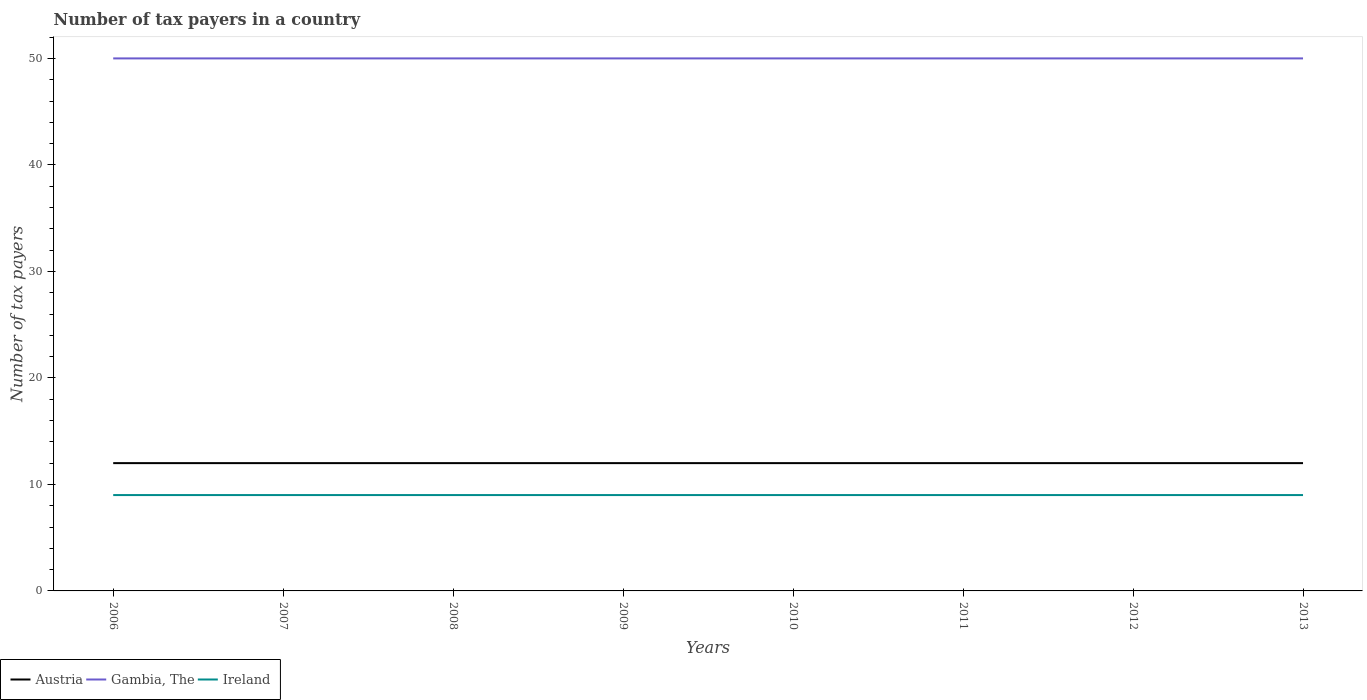How many different coloured lines are there?
Ensure brevity in your answer.  3. Does the line corresponding to Gambia, The intersect with the line corresponding to Ireland?
Offer a terse response. No. Across all years, what is the maximum number of tax payers in in Gambia, The?
Give a very brief answer. 50. In which year was the number of tax payers in in Gambia, The maximum?
Offer a terse response. 2006. What is the difference between the highest and the second highest number of tax payers in in Ireland?
Ensure brevity in your answer.  0. Is the number of tax payers in in Gambia, The strictly greater than the number of tax payers in in Ireland over the years?
Your answer should be very brief. No. Does the graph contain any zero values?
Your response must be concise. No. Does the graph contain grids?
Your answer should be very brief. No. How many legend labels are there?
Keep it short and to the point. 3. How are the legend labels stacked?
Provide a succinct answer. Horizontal. What is the title of the graph?
Give a very brief answer. Number of tax payers in a country. What is the label or title of the X-axis?
Make the answer very short. Years. What is the label or title of the Y-axis?
Offer a terse response. Number of tax payers. What is the Number of tax payers of Austria in 2006?
Your answer should be very brief. 12. What is the Number of tax payers of Gambia, The in 2006?
Offer a terse response. 50. What is the Number of tax payers of Austria in 2007?
Provide a succinct answer. 12. What is the Number of tax payers in Gambia, The in 2007?
Your answer should be compact. 50. What is the Number of tax payers of Ireland in 2007?
Your answer should be compact. 9. What is the Number of tax payers of Austria in 2008?
Make the answer very short. 12. What is the Number of tax payers of Gambia, The in 2008?
Keep it short and to the point. 50. What is the Number of tax payers of Austria in 2009?
Provide a short and direct response. 12. What is the Number of tax payers of Ireland in 2010?
Your answer should be very brief. 9. What is the Number of tax payers in Austria in 2011?
Ensure brevity in your answer.  12. What is the Number of tax payers of Ireland in 2012?
Offer a terse response. 9. What is the Number of tax payers in Austria in 2013?
Your answer should be very brief. 12. What is the Number of tax payers in Gambia, The in 2013?
Your answer should be compact. 50. What is the Number of tax payers of Ireland in 2013?
Your response must be concise. 9. Across all years, what is the maximum Number of tax payers of Austria?
Offer a very short reply. 12. Across all years, what is the maximum Number of tax payers of Gambia, The?
Give a very brief answer. 50. Across all years, what is the maximum Number of tax payers of Ireland?
Your answer should be very brief. 9. Across all years, what is the minimum Number of tax payers in Gambia, The?
Offer a terse response. 50. Across all years, what is the minimum Number of tax payers of Ireland?
Offer a very short reply. 9. What is the total Number of tax payers in Austria in the graph?
Give a very brief answer. 96. What is the total Number of tax payers of Gambia, The in the graph?
Ensure brevity in your answer.  400. What is the difference between the Number of tax payers in Gambia, The in 2006 and that in 2007?
Your response must be concise. 0. What is the difference between the Number of tax payers of Ireland in 2006 and that in 2007?
Offer a very short reply. 0. What is the difference between the Number of tax payers of Ireland in 2006 and that in 2009?
Keep it short and to the point. 0. What is the difference between the Number of tax payers of Gambia, The in 2006 and that in 2010?
Provide a succinct answer. 0. What is the difference between the Number of tax payers in Ireland in 2006 and that in 2010?
Provide a short and direct response. 0. What is the difference between the Number of tax payers in Austria in 2006 and that in 2011?
Ensure brevity in your answer.  0. What is the difference between the Number of tax payers in Gambia, The in 2006 and that in 2012?
Offer a very short reply. 0. What is the difference between the Number of tax payers in Ireland in 2006 and that in 2012?
Give a very brief answer. 0. What is the difference between the Number of tax payers in Austria in 2006 and that in 2013?
Your answer should be compact. 0. What is the difference between the Number of tax payers in Gambia, The in 2007 and that in 2008?
Ensure brevity in your answer.  0. What is the difference between the Number of tax payers of Ireland in 2007 and that in 2008?
Give a very brief answer. 0. What is the difference between the Number of tax payers in Austria in 2007 and that in 2009?
Provide a short and direct response. 0. What is the difference between the Number of tax payers in Gambia, The in 2007 and that in 2009?
Provide a short and direct response. 0. What is the difference between the Number of tax payers of Austria in 2007 and that in 2010?
Your answer should be compact. 0. What is the difference between the Number of tax payers in Gambia, The in 2007 and that in 2010?
Provide a succinct answer. 0. What is the difference between the Number of tax payers in Ireland in 2007 and that in 2010?
Your answer should be very brief. 0. What is the difference between the Number of tax payers in Austria in 2007 and that in 2011?
Keep it short and to the point. 0. What is the difference between the Number of tax payers of Gambia, The in 2007 and that in 2012?
Keep it short and to the point. 0. What is the difference between the Number of tax payers of Ireland in 2007 and that in 2012?
Provide a succinct answer. 0. What is the difference between the Number of tax payers in Gambia, The in 2007 and that in 2013?
Your answer should be compact. 0. What is the difference between the Number of tax payers in Ireland in 2007 and that in 2013?
Keep it short and to the point. 0. What is the difference between the Number of tax payers of Austria in 2008 and that in 2010?
Your answer should be compact. 0. What is the difference between the Number of tax payers of Gambia, The in 2008 and that in 2010?
Provide a succinct answer. 0. What is the difference between the Number of tax payers in Ireland in 2008 and that in 2010?
Offer a very short reply. 0. What is the difference between the Number of tax payers in Ireland in 2008 and that in 2011?
Your response must be concise. 0. What is the difference between the Number of tax payers in Austria in 2009 and that in 2010?
Ensure brevity in your answer.  0. What is the difference between the Number of tax payers in Austria in 2009 and that in 2011?
Make the answer very short. 0. What is the difference between the Number of tax payers of Ireland in 2009 and that in 2011?
Your answer should be very brief. 0. What is the difference between the Number of tax payers of Gambia, The in 2009 and that in 2012?
Your answer should be very brief. 0. What is the difference between the Number of tax payers of Austria in 2009 and that in 2013?
Make the answer very short. 0. What is the difference between the Number of tax payers of Gambia, The in 2009 and that in 2013?
Provide a short and direct response. 0. What is the difference between the Number of tax payers of Austria in 2010 and that in 2012?
Ensure brevity in your answer.  0. What is the difference between the Number of tax payers in Gambia, The in 2010 and that in 2012?
Keep it short and to the point. 0. What is the difference between the Number of tax payers of Ireland in 2010 and that in 2012?
Keep it short and to the point. 0. What is the difference between the Number of tax payers of Ireland in 2010 and that in 2013?
Give a very brief answer. 0. What is the difference between the Number of tax payers of Austria in 2011 and that in 2012?
Give a very brief answer. 0. What is the difference between the Number of tax payers in Gambia, The in 2011 and that in 2012?
Give a very brief answer. 0. What is the difference between the Number of tax payers in Austria in 2011 and that in 2013?
Provide a succinct answer. 0. What is the difference between the Number of tax payers in Gambia, The in 2011 and that in 2013?
Make the answer very short. 0. What is the difference between the Number of tax payers in Ireland in 2011 and that in 2013?
Your response must be concise. 0. What is the difference between the Number of tax payers of Austria in 2012 and that in 2013?
Ensure brevity in your answer.  0. What is the difference between the Number of tax payers in Gambia, The in 2012 and that in 2013?
Give a very brief answer. 0. What is the difference between the Number of tax payers of Ireland in 2012 and that in 2013?
Provide a succinct answer. 0. What is the difference between the Number of tax payers of Austria in 2006 and the Number of tax payers of Gambia, The in 2007?
Give a very brief answer. -38. What is the difference between the Number of tax payers in Austria in 2006 and the Number of tax payers in Ireland in 2007?
Give a very brief answer. 3. What is the difference between the Number of tax payers in Gambia, The in 2006 and the Number of tax payers in Ireland in 2007?
Offer a very short reply. 41. What is the difference between the Number of tax payers in Austria in 2006 and the Number of tax payers in Gambia, The in 2008?
Your answer should be very brief. -38. What is the difference between the Number of tax payers of Austria in 2006 and the Number of tax payers of Ireland in 2008?
Make the answer very short. 3. What is the difference between the Number of tax payers in Gambia, The in 2006 and the Number of tax payers in Ireland in 2008?
Your answer should be compact. 41. What is the difference between the Number of tax payers of Austria in 2006 and the Number of tax payers of Gambia, The in 2009?
Your answer should be compact. -38. What is the difference between the Number of tax payers of Austria in 2006 and the Number of tax payers of Ireland in 2009?
Offer a very short reply. 3. What is the difference between the Number of tax payers of Austria in 2006 and the Number of tax payers of Gambia, The in 2010?
Make the answer very short. -38. What is the difference between the Number of tax payers of Austria in 2006 and the Number of tax payers of Ireland in 2010?
Your answer should be very brief. 3. What is the difference between the Number of tax payers in Austria in 2006 and the Number of tax payers in Gambia, The in 2011?
Offer a very short reply. -38. What is the difference between the Number of tax payers of Austria in 2006 and the Number of tax payers of Ireland in 2011?
Give a very brief answer. 3. What is the difference between the Number of tax payers in Gambia, The in 2006 and the Number of tax payers in Ireland in 2011?
Your answer should be compact. 41. What is the difference between the Number of tax payers in Austria in 2006 and the Number of tax payers in Gambia, The in 2012?
Offer a terse response. -38. What is the difference between the Number of tax payers in Austria in 2006 and the Number of tax payers in Ireland in 2012?
Your answer should be very brief. 3. What is the difference between the Number of tax payers of Austria in 2006 and the Number of tax payers of Gambia, The in 2013?
Offer a terse response. -38. What is the difference between the Number of tax payers of Gambia, The in 2006 and the Number of tax payers of Ireland in 2013?
Offer a very short reply. 41. What is the difference between the Number of tax payers of Austria in 2007 and the Number of tax payers of Gambia, The in 2008?
Give a very brief answer. -38. What is the difference between the Number of tax payers of Gambia, The in 2007 and the Number of tax payers of Ireland in 2008?
Provide a succinct answer. 41. What is the difference between the Number of tax payers in Austria in 2007 and the Number of tax payers in Gambia, The in 2009?
Provide a succinct answer. -38. What is the difference between the Number of tax payers of Austria in 2007 and the Number of tax payers of Gambia, The in 2010?
Your response must be concise. -38. What is the difference between the Number of tax payers in Austria in 2007 and the Number of tax payers in Gambia, The in 2011?
Offer a very short reply. -38. What is the difference between the Number of tax payers of Gambia, The in 2007 and the Number of tax payers of Ireland in 2011?
Offer a very short reply. 41. What is the difference between the Number of tax payers in Austria in 2007 and the Number of tax payers in Gambia, The in 2012?
Make the answer very short. -38. What is the difference between the Number of tax payers of Austria in 2007 and the Number of tax payers of Gambia, The in 2013?
Provide a succinct answer. -38. What is the difference between the Number of tax payers of Austria in 2007 and the Number of tax payers of Ireland in 2013?
Give a very brief answer. 3. What is the difference between the Number of tax payers in Gambia, The in 2007 and the Number of tax payers in Ireland in 2013?
Your answer should be very brief. 41. What is the difference between the Number of tax payers in Austria in 2008 and the Number of tax payers in Gambia, The in 2009?
Offer a terse response. -38. What is the difference between the Number of tax payers of Austria in 2008 and the Number of tax payers of Ireland in 2009?
Your response must be concise. 3. What is the difference between the Number of tax payers of Austria in 2008 and the Number of tax payers of Gambia, The in 2010?
Provide a short and direct response. -38. What is the difference between the Number of tax payers in Austria in 2008 and the Number of tax payers in Gambia, The in 2011?
Offer a very short reply. -38. What is the difference between the Number of tax payers in Austria in 2008 and the Number of tax payers in Ireland in 2011?
Make the answer very short. 3. What is the difference between the Number of tax payers of Gambia, The in 2008 and the Number of tax payers of Ireland in 2011?
Your answer should be very brief. 41. What is the difference between the Number of tax payers of Austria in 2008 and the Number of tax payers of Gambia, The in 2012?
Give a very brief answer. -38. What is the difference between the Number of tax payers of Gambia, The in 2008 and the Number of tax payers of Ireland in 2012?
Your answer should be very brief. 41. What is the difference between the Number of tax payers in Austria in 2008 and the Number of tax payers in Gambia, The in 2013?
Offer a very short reply. -38. What is the difference between the Number of tax payers of Austria in 2008 and the Number of tax payers of Ireland in 2013?
Give a very brief answer. 3. What is the difference between the Number of tax payers of Austria in 2009 and the Number of tax payers of Gambia, The in 2010?
Make the answer very short. -38. What is the difference between the Number of tax payers in Austria in 2009 and the Number of tax payers in Ireland in 2010?
Ensure brevity in your answer.  3. What is the difference between the Number of tax payers in Austria in 2009 and the Number of tax payers in Gambia, The in 2011?
Make the answer very short. -38. What is the difference between the Number of tax payers of Gambia, The in 2009 and the Number of tax payers of Ireland in 2011?
Your response must be concise. 41. What is the difference between the Number of tax payers in Austria in 2009 and the Number of tax payers in Gambia, The in 2012?
Ensure brevity in your answer.  -38. What is the difference between the Number of tax payers of Austria in 2009 and the Number of tax payers of Gambia, The in 2013?
Your answer should be compact. -38. What is the difference between the Number of tax payers of Austria in 2010 and the Number of tax payers of Gambia, The in 2011?
Offer a very short reply. -38. What is the difference between the Number of tax payers in Austria in 2010 and the Number of tax payers in Ireland in 2011?
Keep it short and to the point. 3. What is the difference between the Number of tax payers in Gambia, The in 2010 and the Number of tax payers in Ireland in 2011?
Give a very brief answer. 41. What is the difference between the Number of tax payers in Austria in 2010 and the Number of tax payers in Gambia, The in 2012?
Offer a terse response. -38. What is the difference between the Number of tax payers of Austria in 2010 and the Number of tax payers of Ireland in 2012?
Provide a succinct answer. 3. What is the difference between the Number of tax payers of Austria in 2010 and the Number of tax payers of Gambia, The in 2013?
Keep it short and to the point. -38. What is the difference between the Number of tax payers in Austria in 2011 and the Number of tax payers in Gambia, The in 2012?
Give a very brief answer. -38. What is the difference between the Number of tax payers of Austria in 2011 and the Number of tax payers of Ireland in 2012?
Provide a short and direct response. 3. What is the difference between the Number of tax payers in Gambia, The in 2011 and the Number of tax payers in Ireland in 2012?
Provide a short and direct response. 41. What is the difference between the Number of tax payers in Austria in 2011 and the Number of tax payers in Gambia, The in 2013?
Give a very brief answer. -38. What is the difference between the Number of tax payers in Austria in 2012 and the Number of tax payers in Gambia, The in 2013?
Offer a terse response. -38. What is the difference between the Number of tax payers in Gambia, The in 2012 and the Number of tax payers in Ireland in 2013?
Provide a succinct answer. 41. What is the average Number of tax payers of Gambia, The per year?
Your answer should be compact. 50. What is the average Number of tax payers in Ireland per year?
Provide a succinct answer. 9. In the year 2006, what is the difference between the Number of tax payers in Austria and Number of tax payers in Gambia, The?
Ensure brevity in your answer.  -38. In the year 2006, what is the difference between the Number of tax payers in Gambia, The and Number of tax payers in Ireland?
Provide a succinct answer. 41. In the year 2007, what is the difference between the Number of tax payers in Austria and Number of tax payers in Gambia, The?
Offer a terse response. -38. In the year 2007, what is the difference between the Number of tax payers of Austria and Number of tax payers of Ireland?
Ensure brevity in your answer.  3. In the year 2007, what is the difference between the Number of tax payers of Gambia, The and Number of tax payers of Ireland?
Offer a terse response. 41. In the year 2008, what is the difference between the Number of tax payers of Austria and Number of tax payers of Gambia, The?
Ensure brevity in your answer.  -38. In the year 2008, what is the difference between the Number of tax payers in Austria and Number of tax payers in Ireland?
Keep it short and to the point. 3. In the year 2009, what is the difference between the Number of tax payers of Austria and Number of tax payers of Gambia, The?
Provide a succinct answer. -38. In the year 2010, what is the difference between the Number of tax payers of Austria and Number of tax payers of Gambia, The?
Keep it short and to the point. -38. In the year 2011, what is the difference between the Number of tax payers of Austria and Number of tax payers of Gambia, The?
Offer a terse response. -38. In the year 2012, what is the difference between the Number of tax payers in Austria and Number of tax payers in Gambia, The?
Your response must be concise. -38. In the year 2012, what is the difference between the Number of tax payers of Austria and Number of tax payers of Ireland?
Give a very brief answer. 3. In the year 2012, what is the difference between the Number of tax payers of Gambia, The and Number of tax payers of Ireland?
Ensure brevity in your answer.  41. In the year 2013, what is the difference between the Number of tax payers in Austria and Number of tax payers in Gambia, The?
Your answer should be compact. -38. In the year 2013, what is the difference between the Number of tax payers of Austria and Number of tax payers of Ireland?
Your response must be concise. 3. In the year 2013, what is the difference between the Number of tax payers in Gambia, The and Number of tax payers in Ireland?
Your answer should be compact. 41. What is the ratio of the Number of tax payers of Austria in 2006 to that in 2007?
Give a very brief answer. 1. What is the ratio of the Number of tax payers in Gambia, The in 2006 to that in 2007?
Offer a very short reply. 1. What is the ratio of the Number of tax payers of Ireland in 2006 to that in 2007?
Your answer should be very brief. 1. What is the ratio of the Number of tax payers in Austria in 2006 to that in 2008?
Provide a short and direct response. 1. What is the ratio of the Number of tax payers of Ireland in 2006 to that in 2009?
Your response must be concise. 1. What is the ratio of the Number of tax payers of Austria in 2006 to that in 2011?
Give a very brief answer. 1. What is the ratio of the Number of tax payers in Ireland in 2006 to that in 2011?
Make the answer very short. 1. What is the ratio of the Number of tax payers of Austria in 2006 to that in 2012?
Offer a terse response. 1. What is the ratio of the Number of tax payers in Gambia, The in 2006 to that in 2012?
Keep it short and to the point. 1. What is the ratio of the Number of tax payers in Gambia, The in 2006 to that in 2013?
Offer a terse response. 1. What is the ratio of the Number of tax payers of Ireland in 2007 to that in 2008?
Offer a very short reply. 1. What is the ratio of the Number of tax payers of Austria in 2007 to that in 2009?
Your response must be concise. 1. What is the ratio of the Number of tax payers in Ireland in 2007 to that in 2009?
Offer a very short reply. 1. What is the ratio of the Number of tax payers in Austria in 2007 to that in 2010?
Your answer should be very brief. 1. What is the ratio of the Number of tax payers of Ireland in 2007 to that in 2010?
Give a very brief answer. 1. What is the ratio of the Number of tax payers in Austria in 2007 to that in 2011?
Your response must be concise. 1. What is the ratio of the Number of tax payers in Gambia, The in 2007 to that in 2011?
Make the answer very short. 1. What is the ratio of the Number of tax payers of Austria in 2007 to that in 2012?
Your answer should be very brief. 1. What is the ratio of the Number of tax payers in Ireland in 2007 to that in 2012?
Your answer should be compact. 1. What is the ratio of the Number of tax payers of Gambia, The in 2007 to that in 2013?
Give a very brief answer. 1. What is the ratio of the Number of tax payers in Ireland in 2007 to that in 2013?
Keep it short and to the point. 1. What is the ratio of the Number of tax payers of Gambia, The in 2008 to that in 2009?
Keep it short and to the point. 1. What is the ratio of the Number of tax payers of Austria in 2008 to that in 2010?
Ensure brevity in your answer.  1. What is the ratio of the Number of tax payers in Gambia, The in 2008 to that in 2010?
Your answer should be very brief. 1. What is the ratio of the Number of tax payers of Ireland in 2008 to that in 2011?
Provide a succinct answer. 1. What is the ratio of the Number of tax payers in Austria in 2008 to that in 2012?
Your response must be concise. 1. What is the ratio of the Number of tax payers of Austria in 2008 to that in 2013?
Your response must be concise. 1. What is the ratio of the Number of tax payers of Gambia, The in 2009 to that in 2010?
Keep it short and to the point. 1. What is the ratio of the Number of tax payers of Ireland in 2009 to that in 2010?
Provide a succinct answer. 1. What is the ratio of the Number of tax payers in Austria in 2009 to that in 2011?
Your response must be concise. 1. What is the ratio of the Number of tax payers in Ireland in 2009 to that in 2011?
Your answer should be very brief. 1. What is the ratio of the Number of tax payers in Austria in 2009 to that in 2012?
Ensure brevity in your answer.  1. What is the ratio of the Number of tax payers of Gambia, The in 2009 to that in 2012?
Ensure brevity in your answer.  1. What is the ratio of the Number of tax payers of Ireland in 2009 to that in 2012?
Your response must be concise. 1. What is the ratio of the Number of tax payers in Austria in 2010 to that in 2011?
Offer a terse response. 1. What is the ratio of the Number of tax payers of Ireland in 2010 to that in 2013?
Ensure brevity in your answer.  1. What is the ratio of the Number of tax payers in Austria in 2011 to that in 2012?
Ensure brevity in your answer.  1. What is the ratio of the Number of tax payers in Gambia, The in 2011 to that in 2012?
Offer a very short reply. 1. What is the ratio of the Number of tax payers in Austria in 2011 to that in 2013?
Provide a short and direct response. 1. What is the ratio of the Number of tax payers in Gambia, The in 2011 to that in 2013?
Ensure brevity in your answer.  1. What is the ratio of the Number of tax payers in Austria in 2012 to that in 2013?
Your response must be concise. 1. What is the ratio of the Number of tax payers of Gambia, The in 2012 to that in 2013?
Your answer should be compact. 1. What is the ratio of the Number of tax payers in Ireland in 2012 to that in 2013?
Keep it short and to the point. 1. What is the difference between the highest and the second highest Number of tax payers of Ireland?
Provide a succinct answer. 0. What is the difference between the highest and the lowest Number of tax payers of Ireland?
Your response must be concise. 0. 